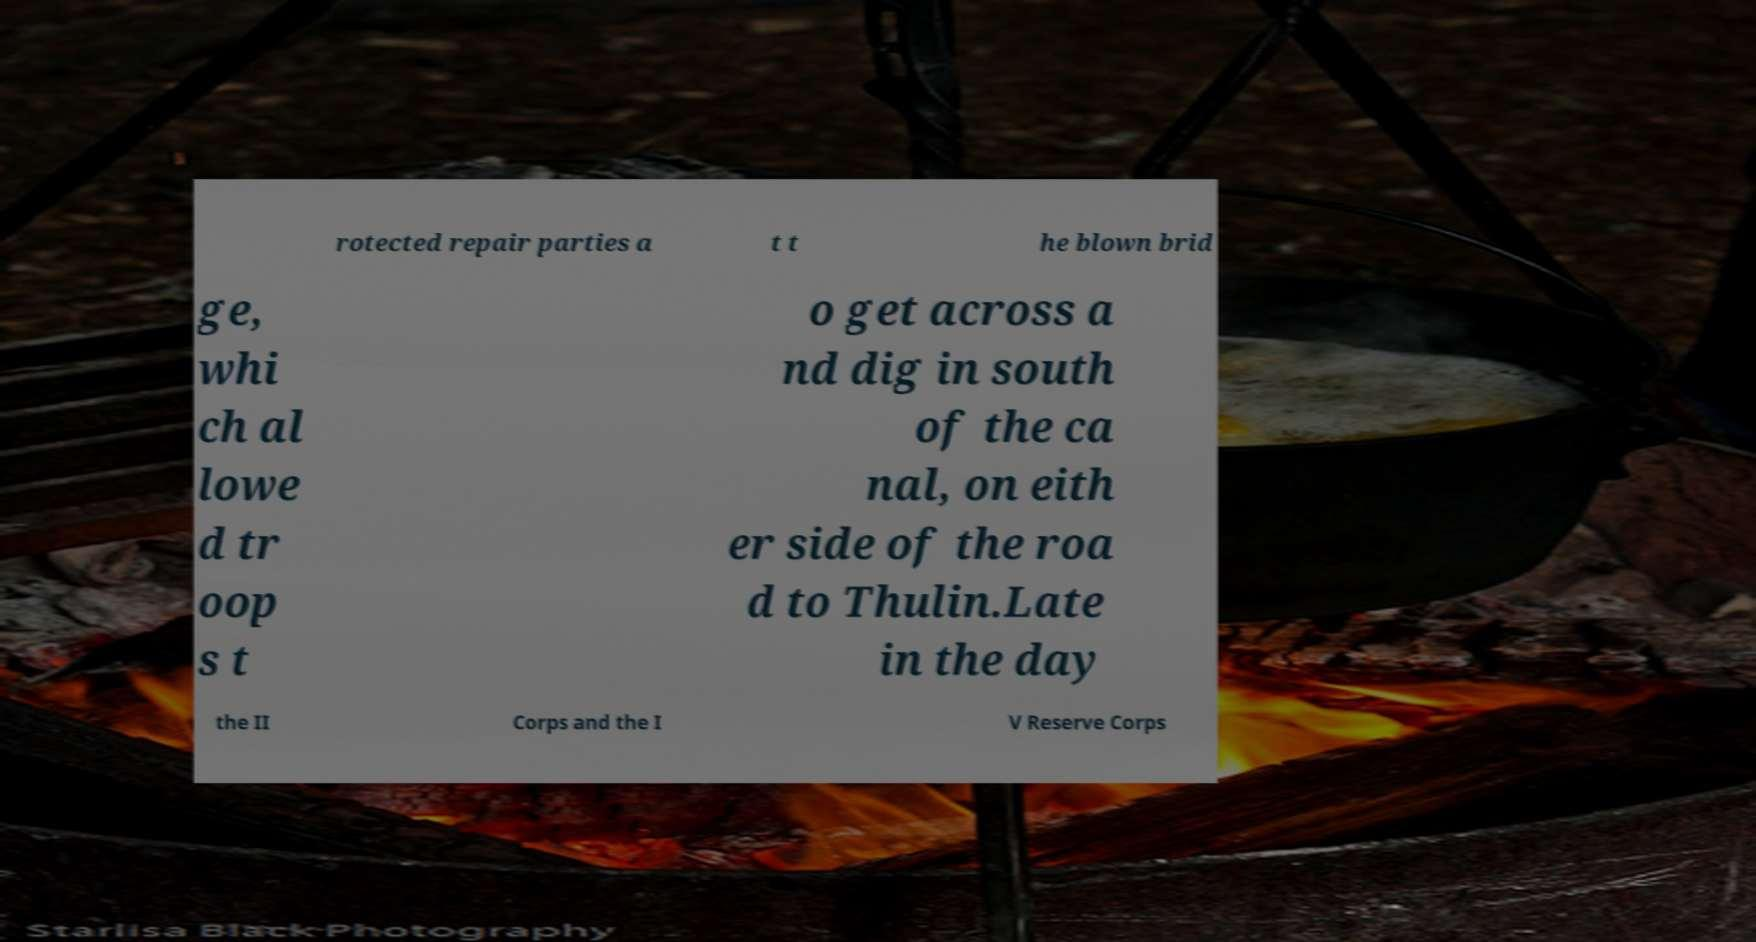Could you assist in decoding the text presented in this image and type it out clearly? rotected repair parties a t t he blown brid ge, whi ch al lowe d tr oop s t o get across a nd dig in south of the ca nal, on eith er side of the roa d to Thulin.Late in the day the II Corps and the I V Reserve Corps 